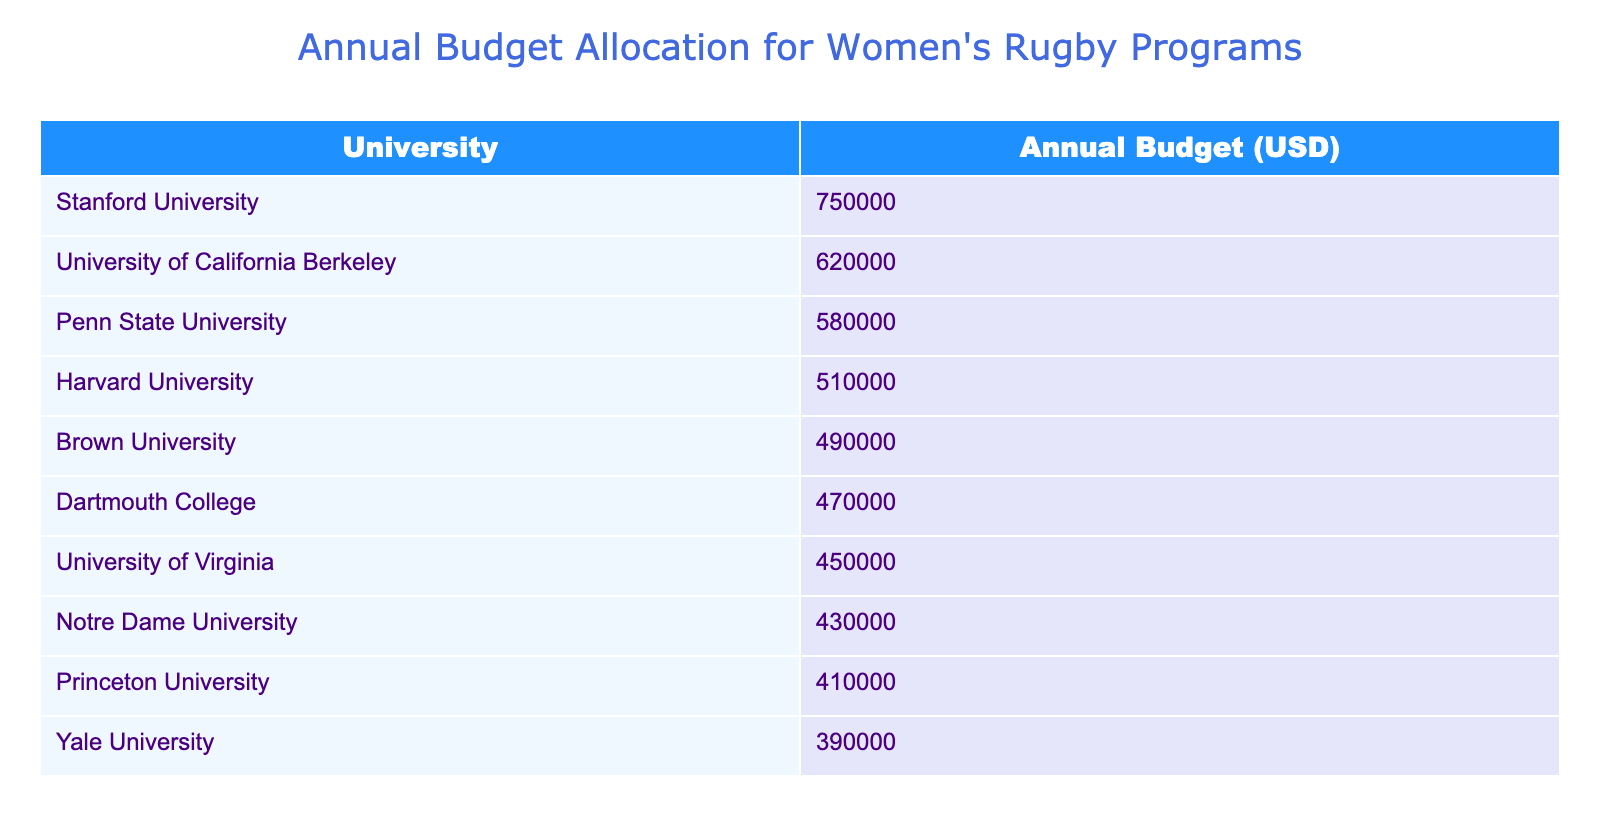What is the highest annual budget allocation for women's rugby programs among the universities listed? The table shows that Stanford University has the highest budget at 750,000 USD.
Answer: 750000 Which university has the lowest annual budget for women's rugby? According to the table, Yale University has the lowest allocation at 390,000 USD.
Answer: 390000 What is the total annual budget allocation for women's rugby at the top three universities? To find the total, sum the budgets of Stanford (750,000), UC Berkeley (620,000), and Penn State (580,000): 750,000 + 620,000 + 580,000 = 1,950,000 USD.
Answer: 1950000 Is the annual budget of Princeton University greater than that of the University of Virginia? The budget for Princeton University is 410,000 USD and for the University of Virginia is 450,000 USD. Since 410,000 is less than 450,000, the answer is no.
Answer: No What is the average annual budget allocation for women's rugby programs of the eight universities except for Stanford University? To calculate the average for the remaining universities, first find their total: 620,000 + 580,000 + 510,000 + 490,000 + 470,000 + 450,000 + 430,000 + 410,000 = 3,560,000. There are 8 universities, so the average is 3,560,000 / 8 = 445,000.
Answer: 445000 How many universities have an annual budget of 500,000 USD or less? The universities with budgets of 500,000 USD or less are Brown (490,000), Dartmouth (470,000), University of Virginia (450,000), Notre Dame (430,000), Princeton (410,000), and Yale (390,000). Altogether that makes six universities.
Answer: 6 What is the difference between Stanford University's budget and that of Yale University? The budget for Stanford is 750,000 USD and for Yale is 390,000 USD. The difference is 750,000 - 390,000 = 360,000 USD.
Answer: 360000 Which university's budget is closer to the average budget of all the universities listed? First, calculate the total budget of all 10 universities which is 3,910,000 USD and the average budget is 3,910,000 / 10 = 391,000 USD. Yale University with a budget of 390,000 USD is closest to the average compared to others.
Answer: Yale University How many universities have budgets greater than 500,000 USD? The universities with budgets greater than 500,000 USD are Stanford (750,000) and UC Berkeley (620,000). Therefore, there are two universities with such budgets.
Answer: 2 